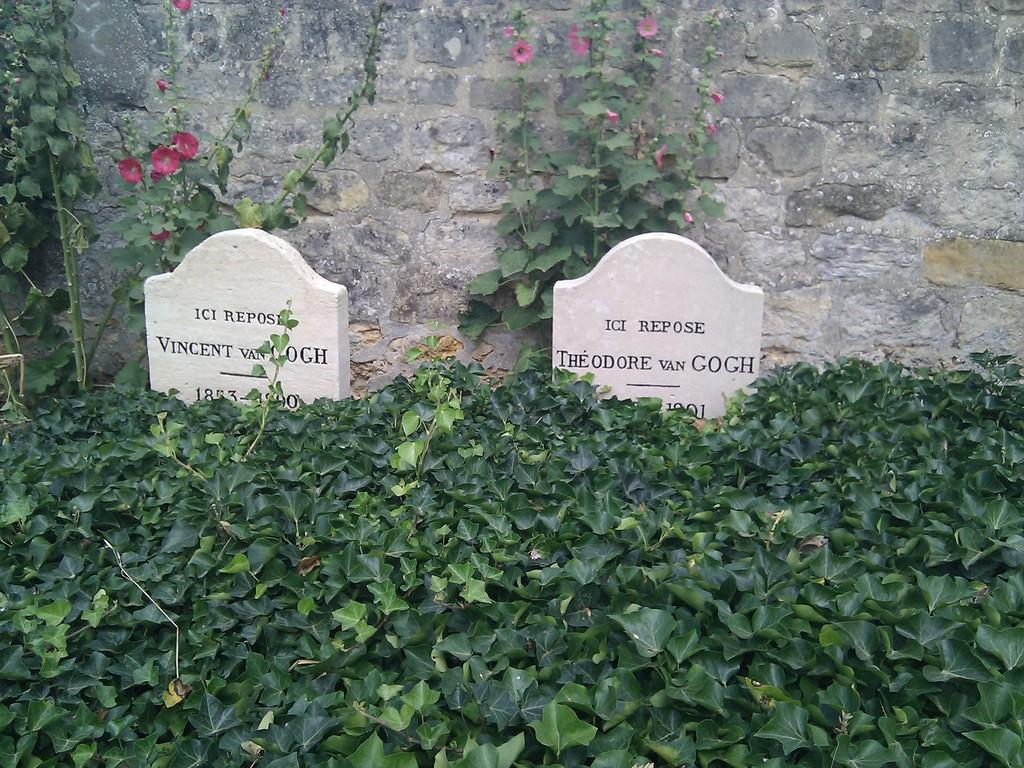<image>
Describe the image concisely. A grave stone that has the name van gogh on it 